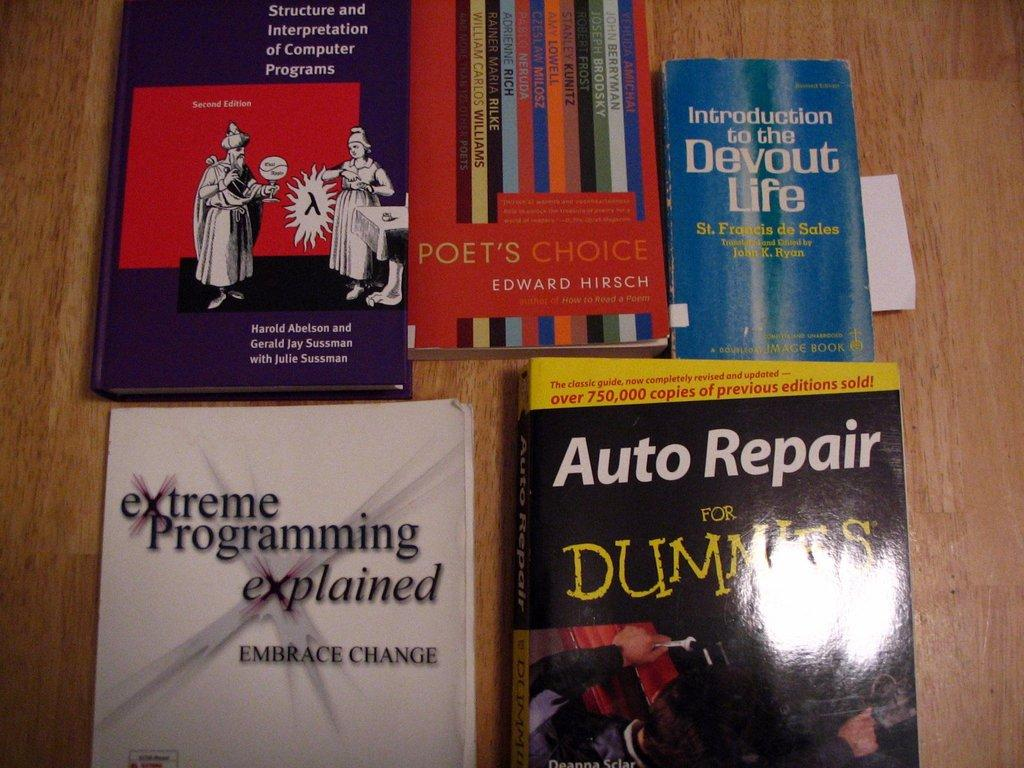<image>
Provide a brief description of the given image. Introduction to the Devout Life sits with some other books on a table. 